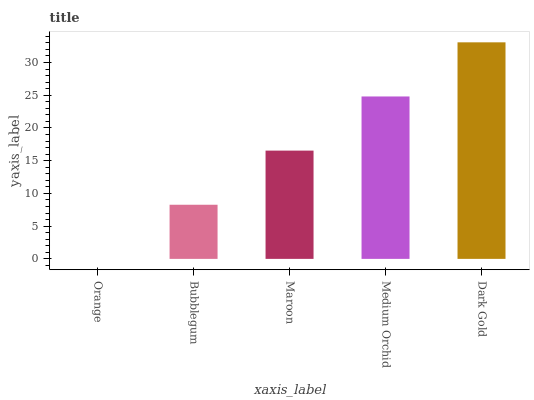Is Orange the minimum?
Answer yes or no. Yes. Is Dark Gold the maximum?
Answer yes or no. Yes. Is Bubblegum the minimum?
Answer yes or no. No. Is Bubblegum the maximum?
Answer yes or no. No. Is Bubblegum greater than Orange?
Answer yes or no. Yes. Is Orange less than Bubblegum?
Answer yes or no. Yes. Is Orange greater than Bubblegum?
Answer yes or no. No. Is Bubblegum less than Orange?
Answer yes or no. No. Is Maroon the high median?
Answer yes or no. Yes. Is Maroon the low median?
Answer yes or no. Yes. Is Bubblegum the high median?
Answer yes or no. No. Is Dark Gold the low median?
Answer yes or no. No. 